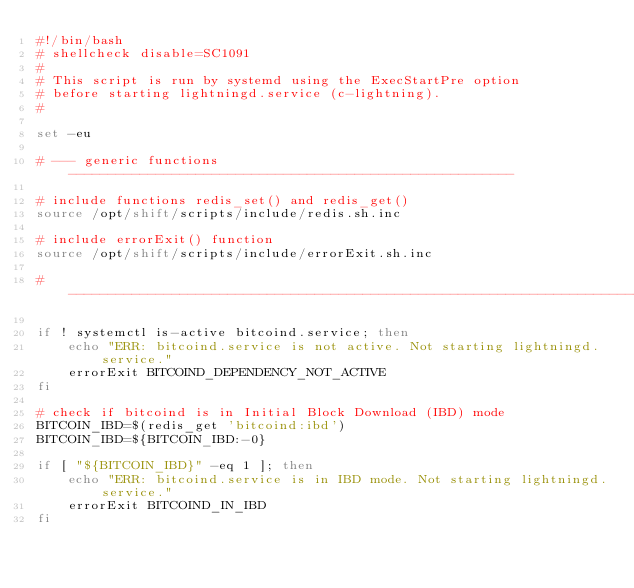Convert code to text. <code><loc_0><loc_0><loc_500><loc_500><_Bash_>#!/bin/bash
# shellcheck disable=SC1091
#
# This script is run by systemd using the ExecStartPre option
# before starting lightningd.service (c-lightning).
#

set -eu

# --- generic functions --------------------------------------------------------

# include functions redis_set() and redis_get()
source /opt/shift/scripts/include/redis.sh.inc

# include errorExit() function
source /opt/shift/scripts/include/errorExit.sh.inc

# ------------------------------------------------------------------------------

if ! systemctl is-active bitcoind.service; then
    echo "ERR: bitcoind.service is not active. Not starting lightningd.service."
    errorExit BITCOIND_DEPENDENCY_NOT_ACTIVE
fi

# check if bitcoind is in Initial Block Download (IBD) mode
BITCOIN_IBD=$(redis_get 'bitcoind:ibd')
BITCOIN_IBD=${BITCOIN_IBD:-0}

if [ "${BITCOIN_IBD}" -eq 1 ]; then
    echo "ERR: bitcoind.service is in IBD mode. Not starting lightningd.service."
    errorExit BITCOIND_IN_IBD
fi
</code> 